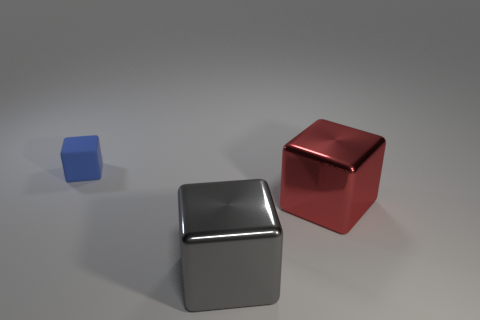What can the differing sizes of the cubes tell us about perspective in this image? The varying sizes of the cubes create a sense of depth in the image. As objects decrease in size, they are commonly perceived as being further away. This visual cue can help viewers understand the spatial relationships between objects within the scene. 